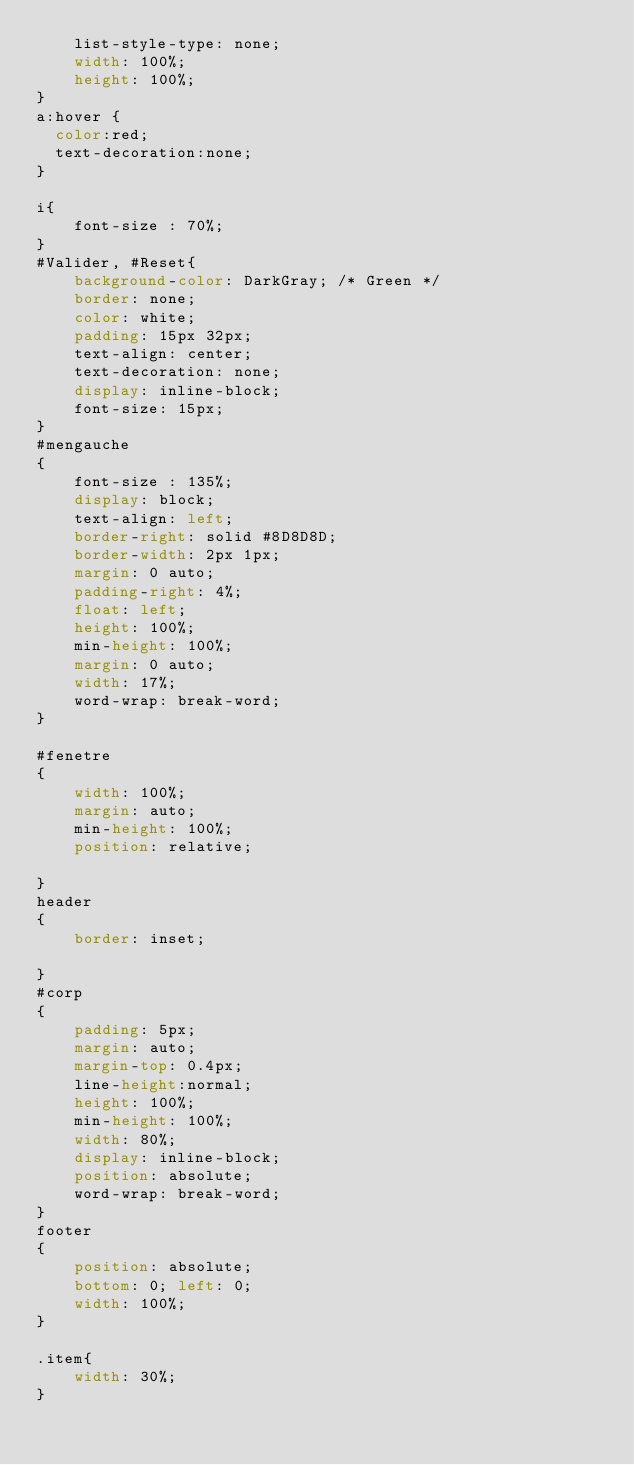<code> <loc_0><loc_0><loc_500><loc_500><_CSS_>    list-style-type: none;
	width: 100%;
	height: 100%;
}
a:hover {
  color:red;
  text-decoration:none;
}

i{
	font-size : 70%;
}
#Valider, #Reset{
    background-color: DarkGray; /* Green */
    border: none;
    color: white;
    padding: 15px 32px;
    text-align: center;
    text-decoration: none;
    display: inline-block;
    font-size: 15px;
}
#mengauche
{
	font-size : 135%;
	display: block;
    text-align: left;
	border-right: solid #8D8D8D;
	border-width: 2px 1px;
	margin: 0 auto;
	padding-right: 4%;
	float: left;
	height: 100%;
	min-height: 100%;
	margin: 0 auto;
	width: 17%;
	word-wrap: break-word;
}

#fenetre
{
	width: 100%;
	margin: auto;
	min-height: 100%;
	position: relative;

}
header
{
	border: inset;

}
#corp
{
	padding: 5px;
	margin: auto;
	margin-top: 0.4px;
	line-height:normal;
	height:	100%;
	min-height: 100%;
	width: 80%;
	display: inline-block;
	position: absolute;
	word-wrap: break-word;
}
footer
{
	position: absolute;
	bottom: 0; left: 0;
	width: 100%;
}

.item{
	width: 30%;
}
</code> 